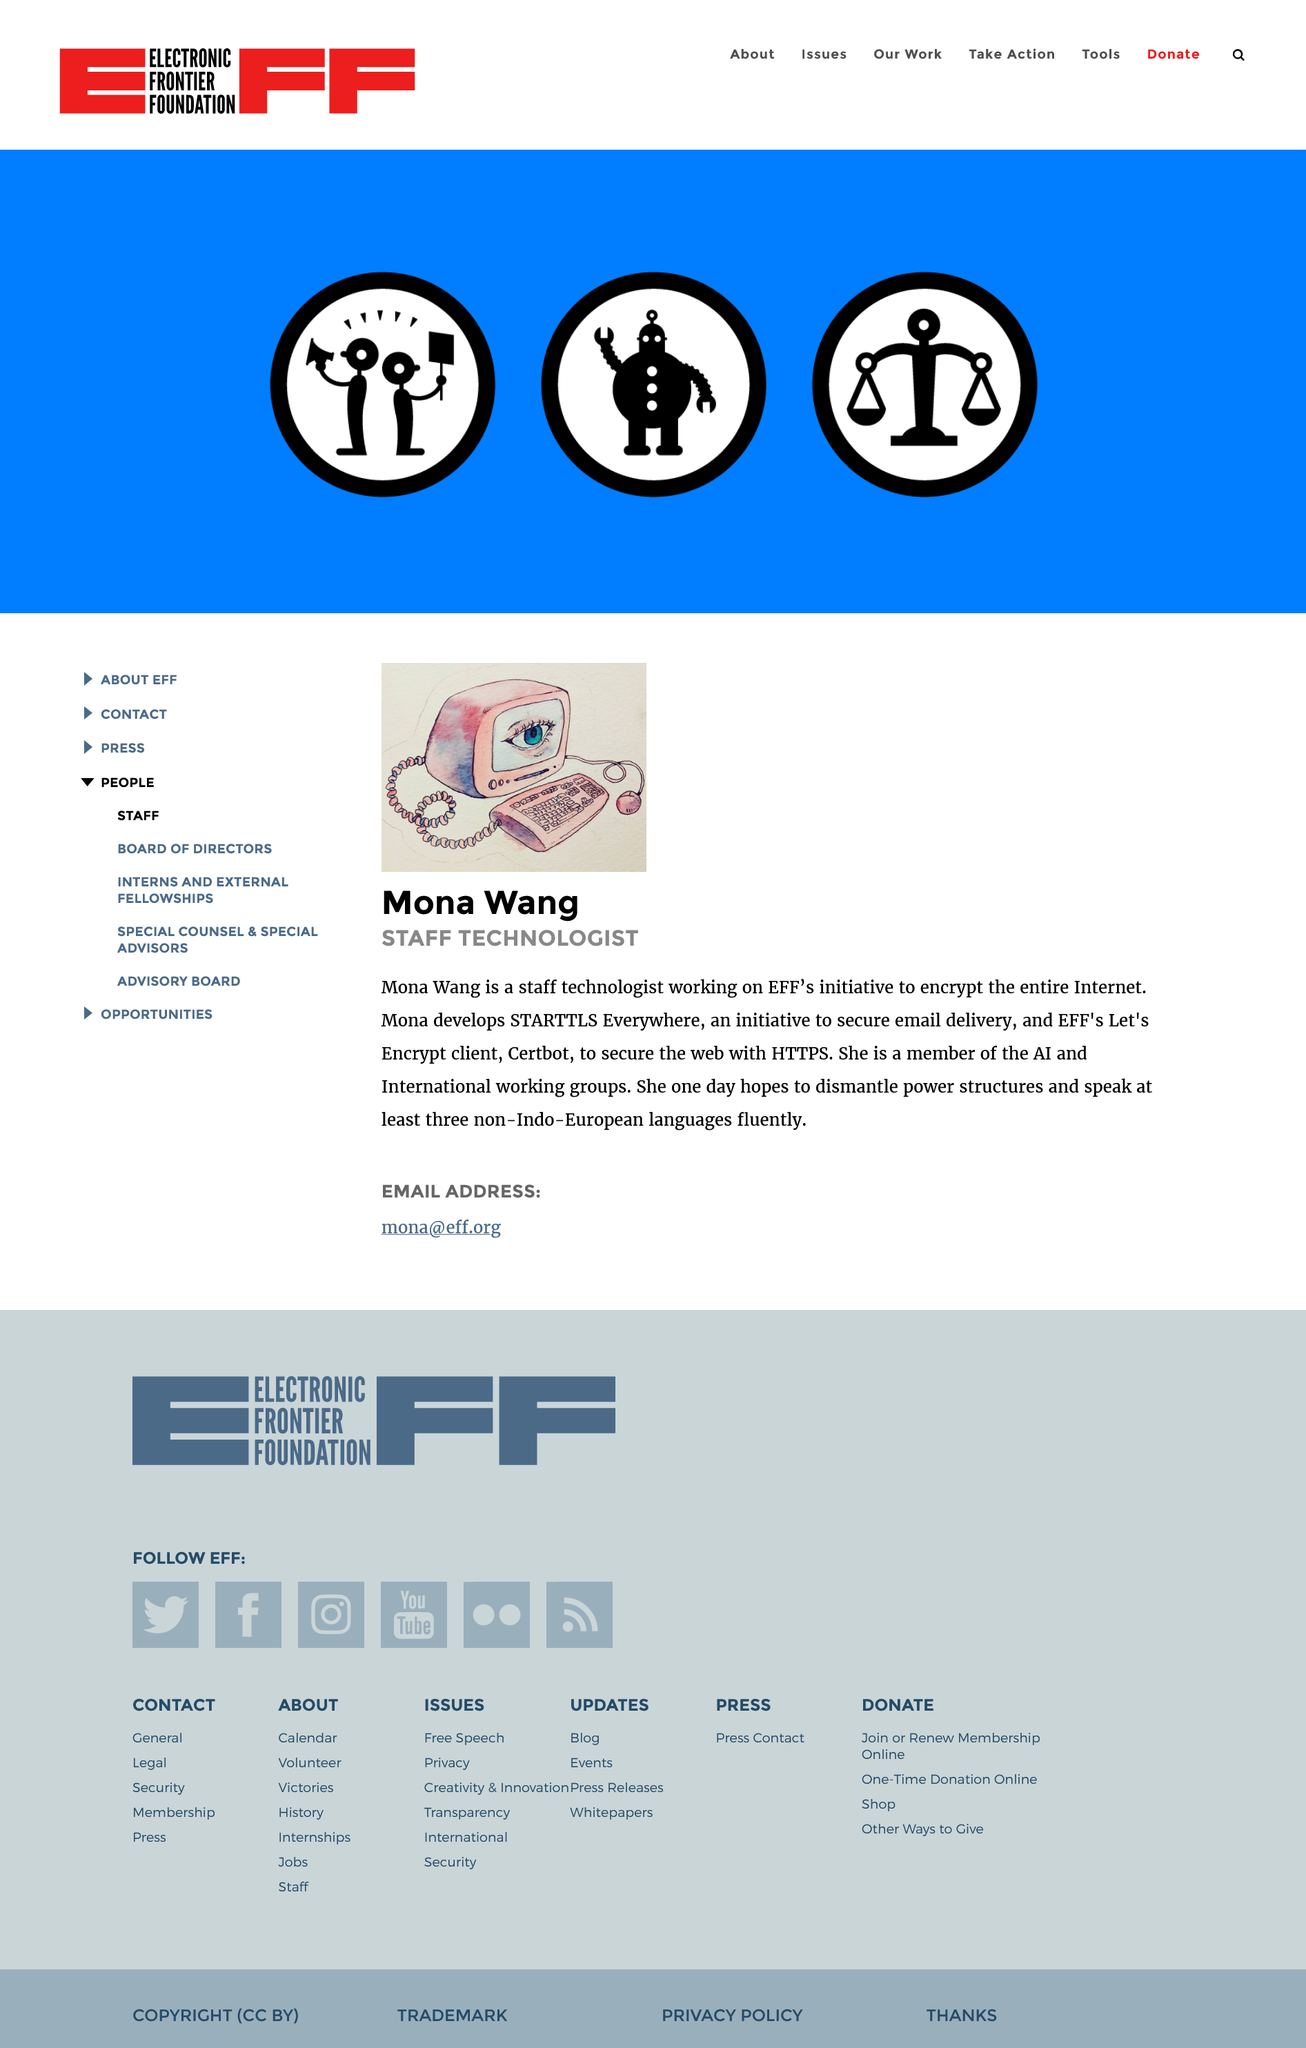Draw attention to some important aspects in this diagram. Member of the AI and International working groups, Mona Wang is... The image associated with Mona Wang features a computer with an eye. Mona Wang is a staff technologist, and her position is well-established within the industry. 